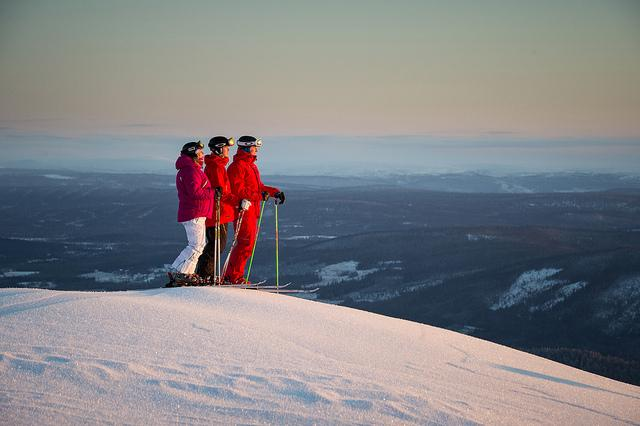What is the most likely time of day? sunset 